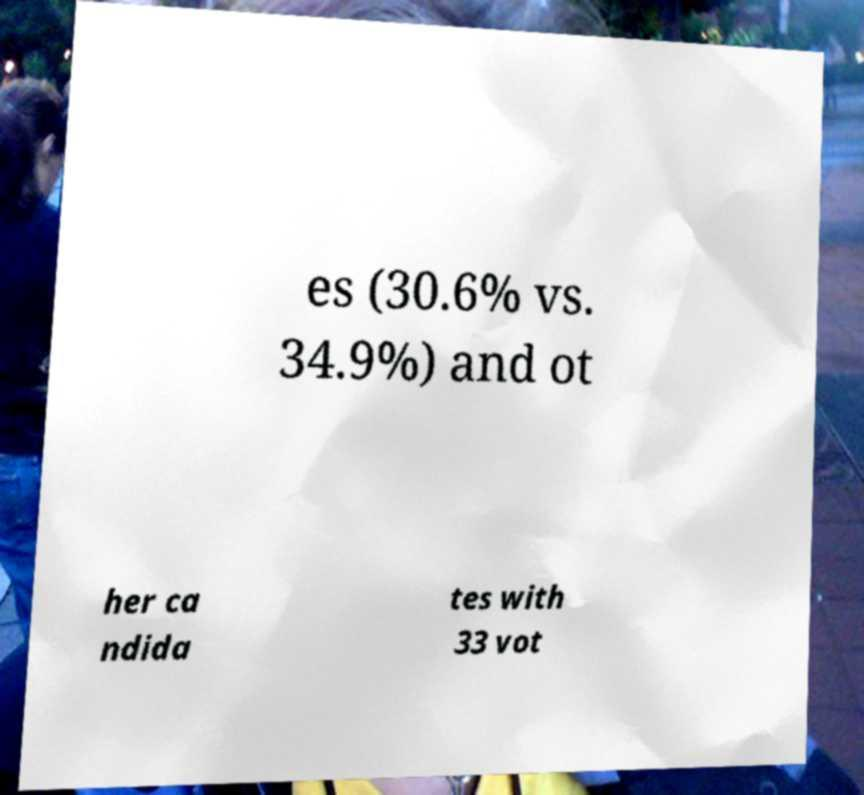Please identify and transcribe the text found in this image. es (30.6% vs. 34.9%) and ot her ca ndida tes with 33 vot 